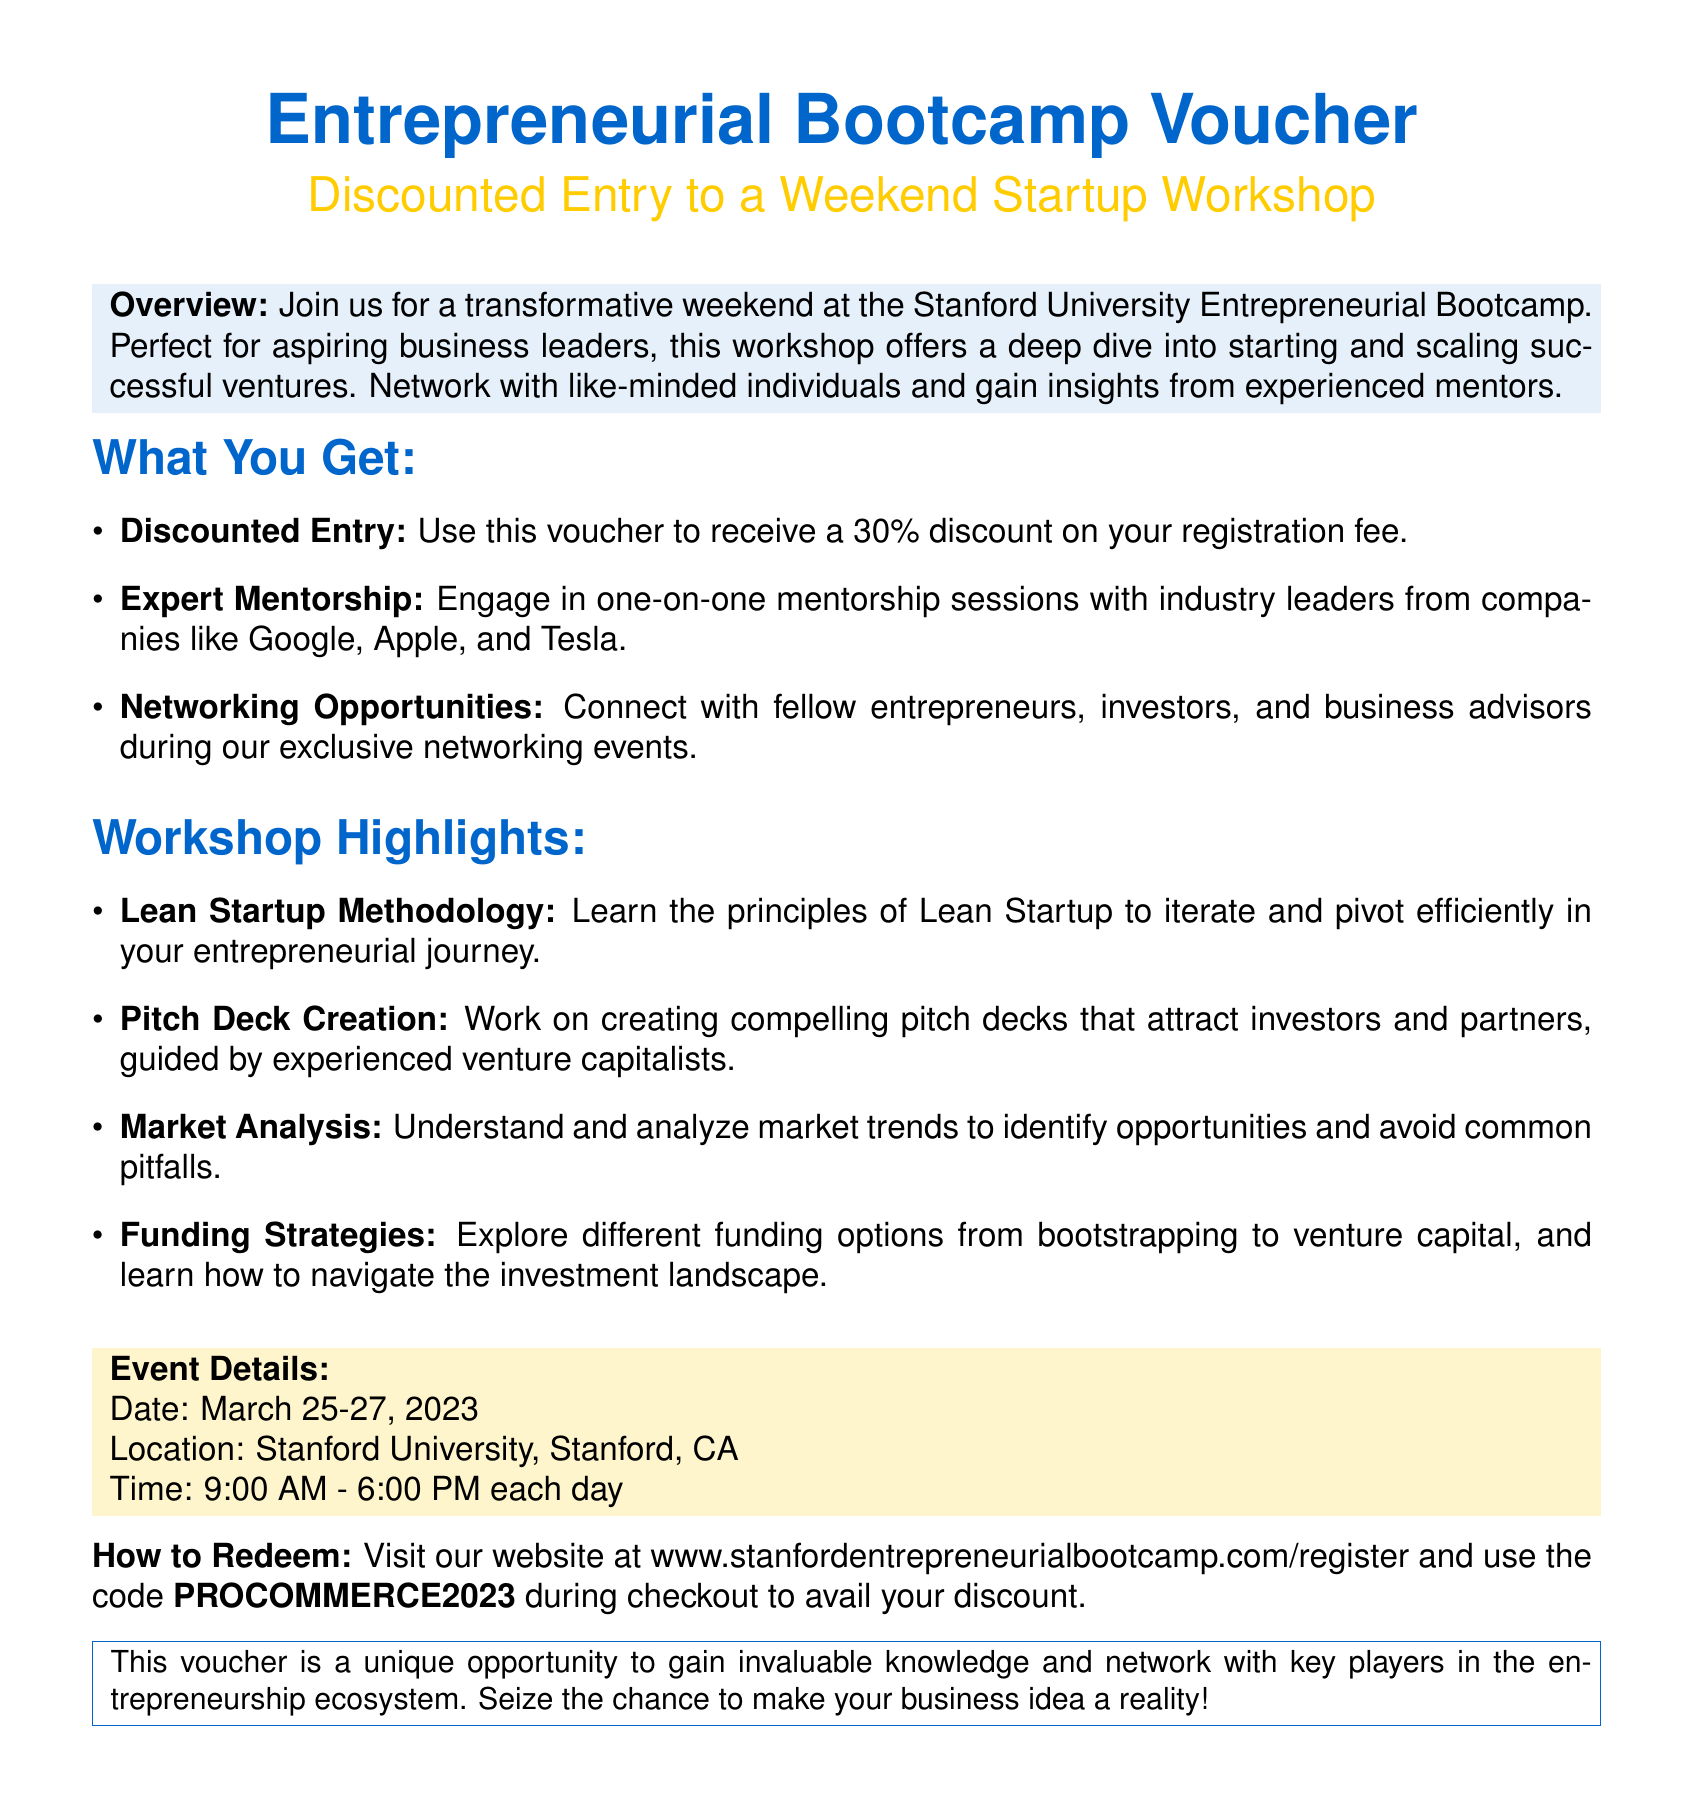What is the discount percentage offered by the voucher? The document states that the voucher provides a 30% discount on the registration fee.
Answer: 30% What is the location of the workshop? The document specifies the location of the event as Stanford University, Stanford, CA.
Answer: Stanford University, Stanford, CA What are the dates of the Entrepreneurial Bootcamp? The event is scheduled from March 25-27, 2023.
Answer: March 25-27, 2023 Who are the industry leaders mentioned for mentorship sessions? The document lists companies like Google, Apple, and Tesla as sources of industry leaders for mentorship.
Answer: Google, Apple, Tesla What is the website to register for the bootcamp? The document provides the website URL for registration as www.stanfordentrepreneurialbootcamp.com/register.
Answer: www.stanfordentrepreneurialbootcamp.com/register What is the time duration of each workshop day? According to the document, the time for each day is from 9:00 AM to 6:00 PM.
Answer: 9:00 AM - 6:00 PM What is one of the highlighted topics in the workshop? The workshop highlights various topics, one of which is the Lean Startup Methodology.
Answer: Lean Startup Methodology How can users redeem their discount? The document explains that users must use the code PROCOMMERCE2023 during checkout to redeem the discount.
Answer: PROCOMMERCE2023 